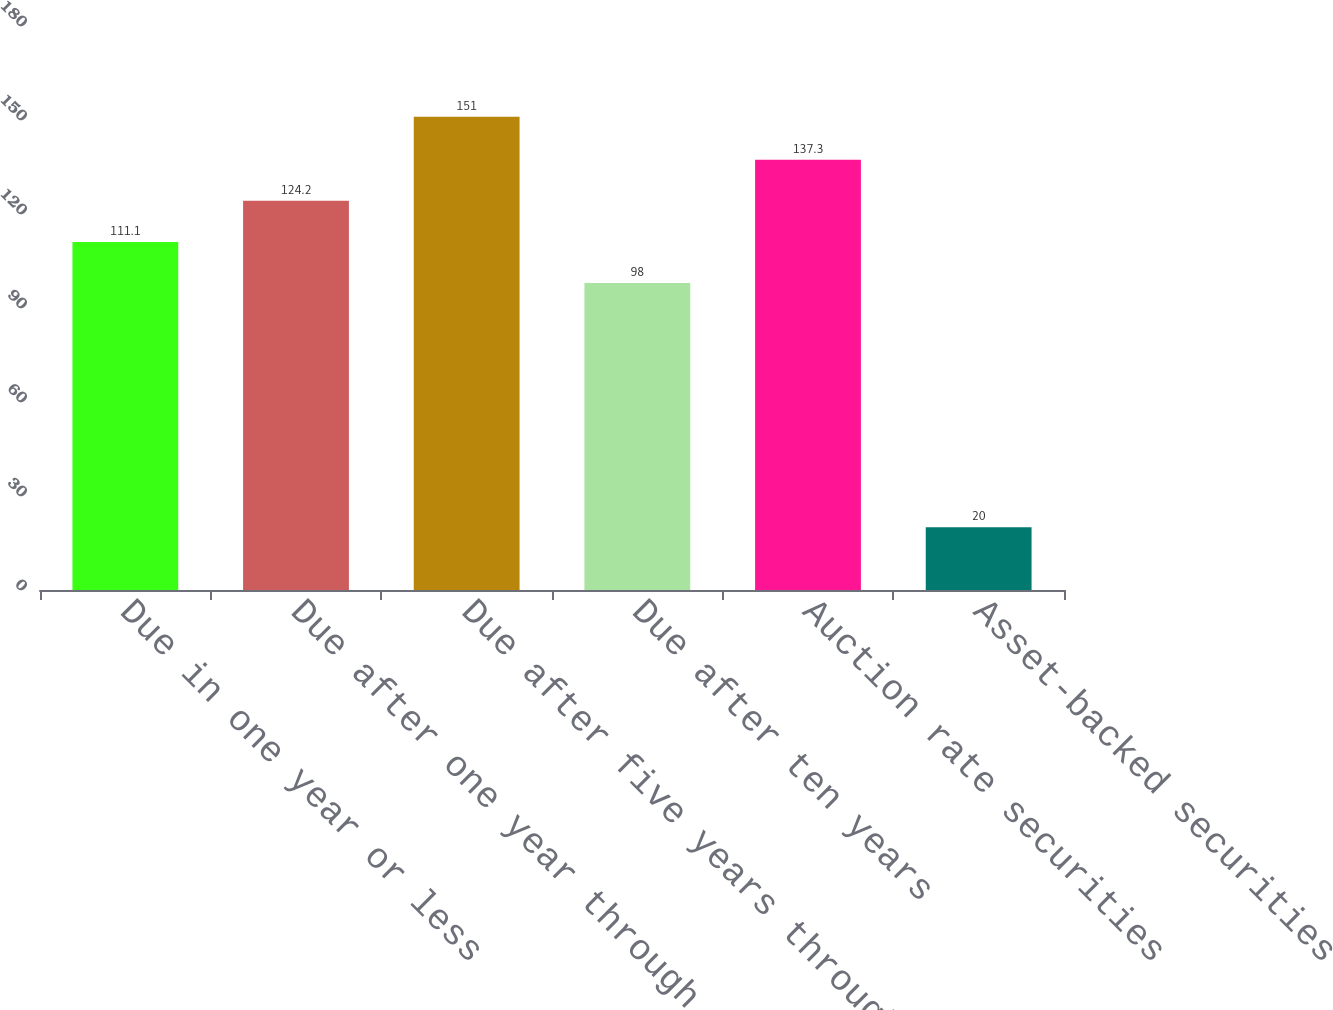Convert chart to OTSL. <chart><loc_0><loc_0><loc_500><loc_500><bar_chart><fcel>Due in one year or less<fcel>Due after one year through<fcel>Due after five years through<fcel>Due after ten years<fcel>Auction rate securities<fcel>Asset-backed securities<nl><fcel>111.1<fcel>124.2<fcel>151<fcel>98<fcel>137.3<fcel>20<nl></chart> 